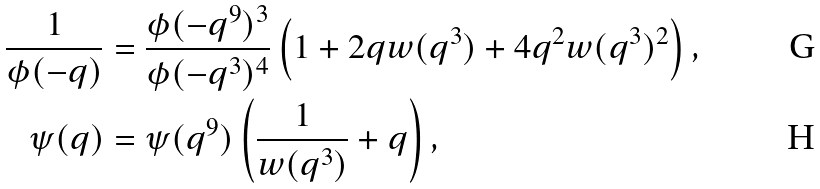<formula> <loc_0><loc_0><loc_500><loc_500>\frac { 1 } { \phi ( - q ) } & = \frac { \phi ( - q ^ { 9 } ) ^ { 3 } } { \phi ( - q ^ { 3 } ) ^ { 4 } } \left ( 1 + 2 q w ( q ^ { 3 } ) + 4 q ^ { 2 } w ( q ^ { 3 } ) ^ { 2 } \right ) , \\ \psi ( q ) & = \psi ( q ^ { 9 } ) \left ( \frac { 1 } { w ( q ^ { 3 } ) } + q \right ) ,</formula> 